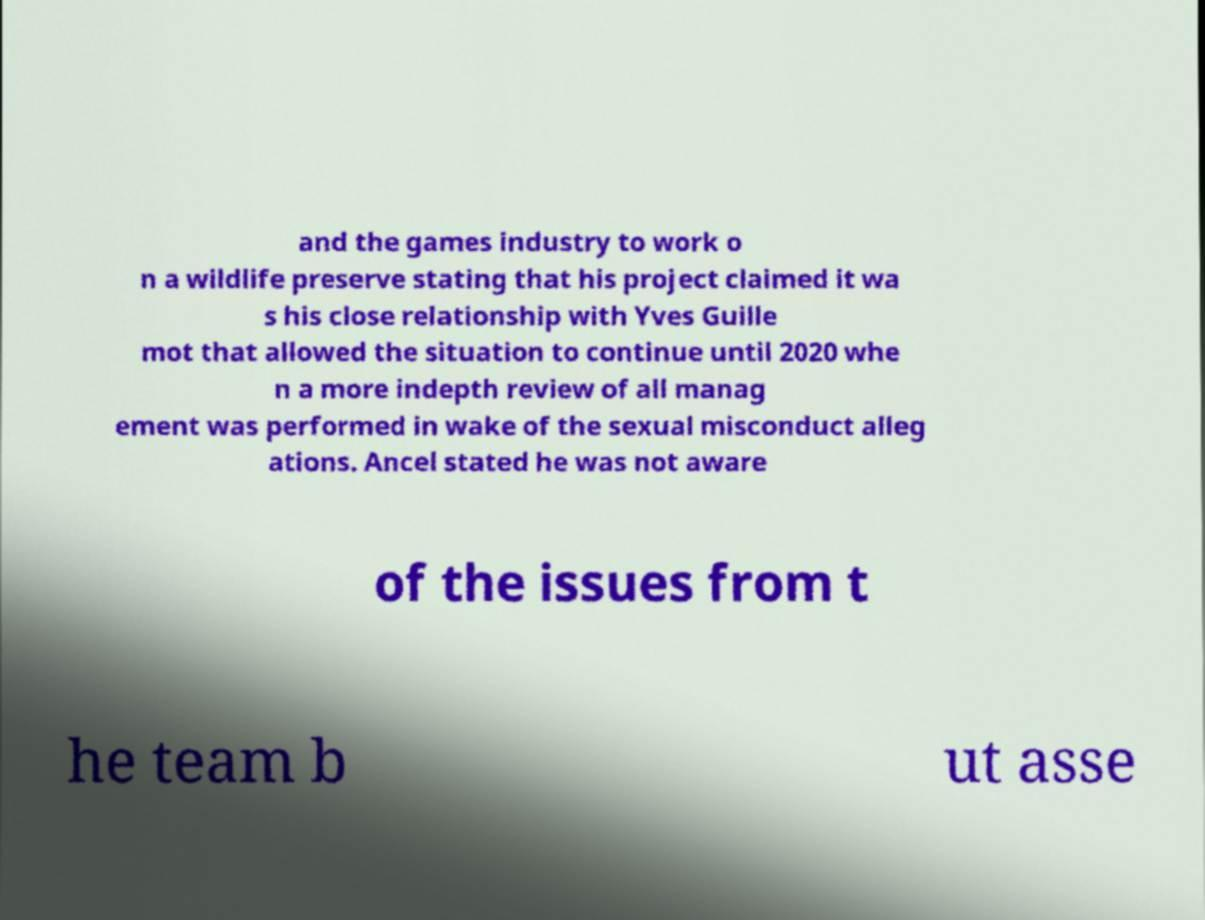I need the written content from this picture converted into text. Can you do that? and the games industry to work o n a wildlife preserve stating that his project claimed it wa s his close relationship with Yves Guille mot that allowed the situation to continue until 2020 whe n a more indepth review of all manag ement was performed in wake of the sexual misconduct alleg ations. Ancel stated he was not aware of the issues from t he team b ut asse 